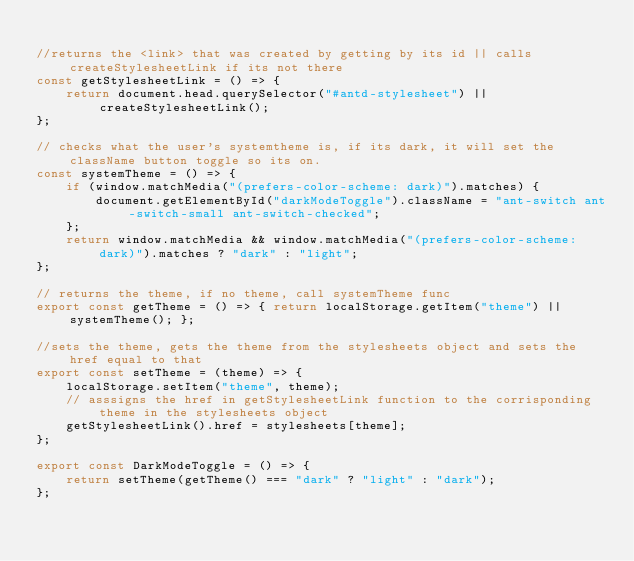<code> <loc_0><loc_0><loc_500><loc_500><_JavaScript_>
//returns the <link> that was created by getting by its id || calls createStylesheetLink if its not there
const getStylesheetLink = () => {
    return document.head.querySelector("#antd-stylesheet") || createStylesheetLink();
};

// checks what the user's systemtheme is, if its dark, it will set the className button toggle so its on.
const systemTheme = () => {
    if (window.matchMedia("(prefers-color-scheme: dark)").matches) {
        document.getElementById("darkModeToggle").className = "ant-switch ant-switch-small ant-switch-checked";
    };
    return window.matchMedia && window.matchMedia("(prefers-color-scheme: dark)").matches ? "dark" : "light";
};

// returns the theme, if no theme, call systemTheme func
export const getTheme = () => { return localStorage.getItem("theme") || systemTheme(); };

//sets the theme, gets the theme from the stylesheets object and sets the href equal to that
export const setTheme = (theme) => {
    localStorage.setItem("theme", theme);
    // asssigns the href in getStylesheetLink function to the corrisponding theme in the stylesheets object 
    getStylesheetLink().href = stylesheets[theme];
};

export const DarkModeToggle = () => { 
    return setTheme(getTheme() === "dark" ? "light" : "dark"); 
};
</code> 